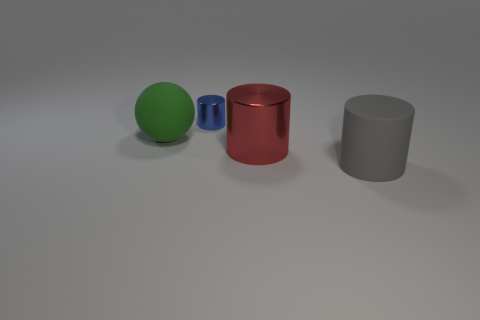Are there any shiny cylinders that have the same size as the sphere?
Ensure brevity in your answer.  Yes. What number of other objects have the same size as the green matte object?
Ensure brevity in your answer.  2. Is the size of the matte thing that is to the left of the gray rubber cylinder the same as the metal cylinder in front of the tiny blue cylinder?
Your response must be concise. Yes. What number of objects are either gray cylinders or matte things that are to the right of the big red shiny object?
Make the answer very short. 1. What is the color of the big matte cylinder?
Your answer should be compact. Gray. The thing on the left side of the tiny metallic cylinder to the left of the metal object in front of the small cylinder is made of what material?
Give a very brief answer. Rubber. There is another thing that is made of the same material as the blue thing; what size is it?
Your answer should be very brief. Large. Is there a big rubber cylinder that has the same color as the big rubber ball?
Ensure brevity in your answer.  No. Does the blue shiny thing have the same size as the metal thing right of the blue shiny object?
Offer a terse response. No. What number of big matte objects are behind the big cylinder behind the matte thing that is on the right side of the tiny metal thing?
Provide a succinct answer. 1. 